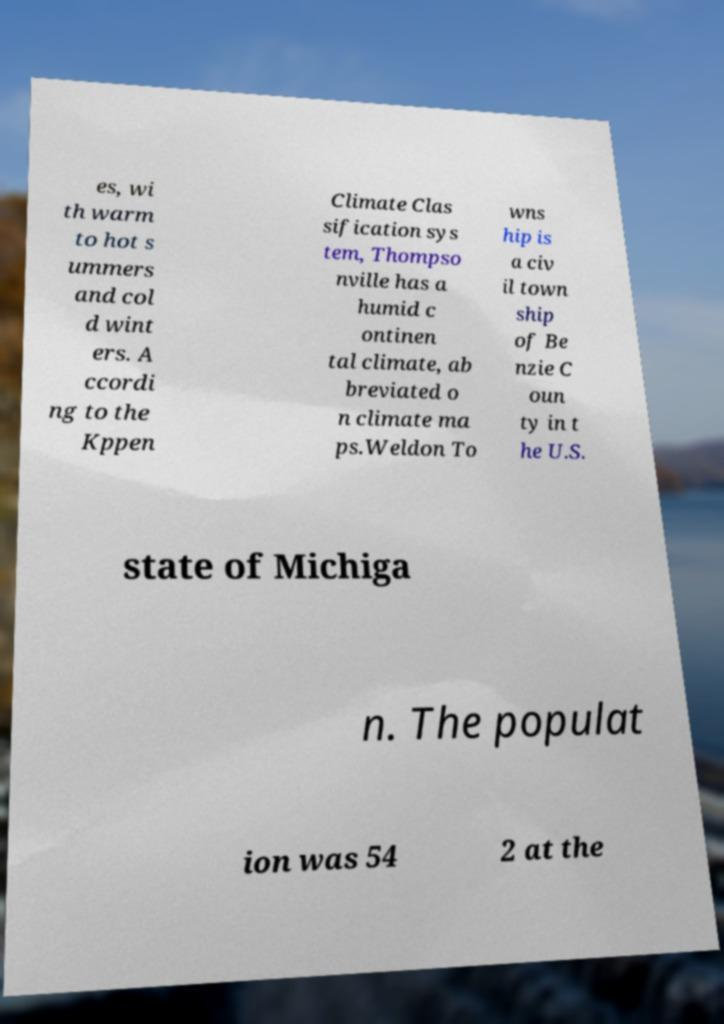I need the written content from this picture converted into text. Can you do that? es, wi th warm to hot s ummers and col d wint ers. A ccordi ng to the Kppen Climate Clas sification sys tem, Thompso nville has a humid c ontinen tal climate, ab breviated o n climate ma ps.Weldon To wns hip is a civ il town ship of Be nzie C oun ty in t he U.S. state of Michiga n. The populat ion was 54 2 at the 